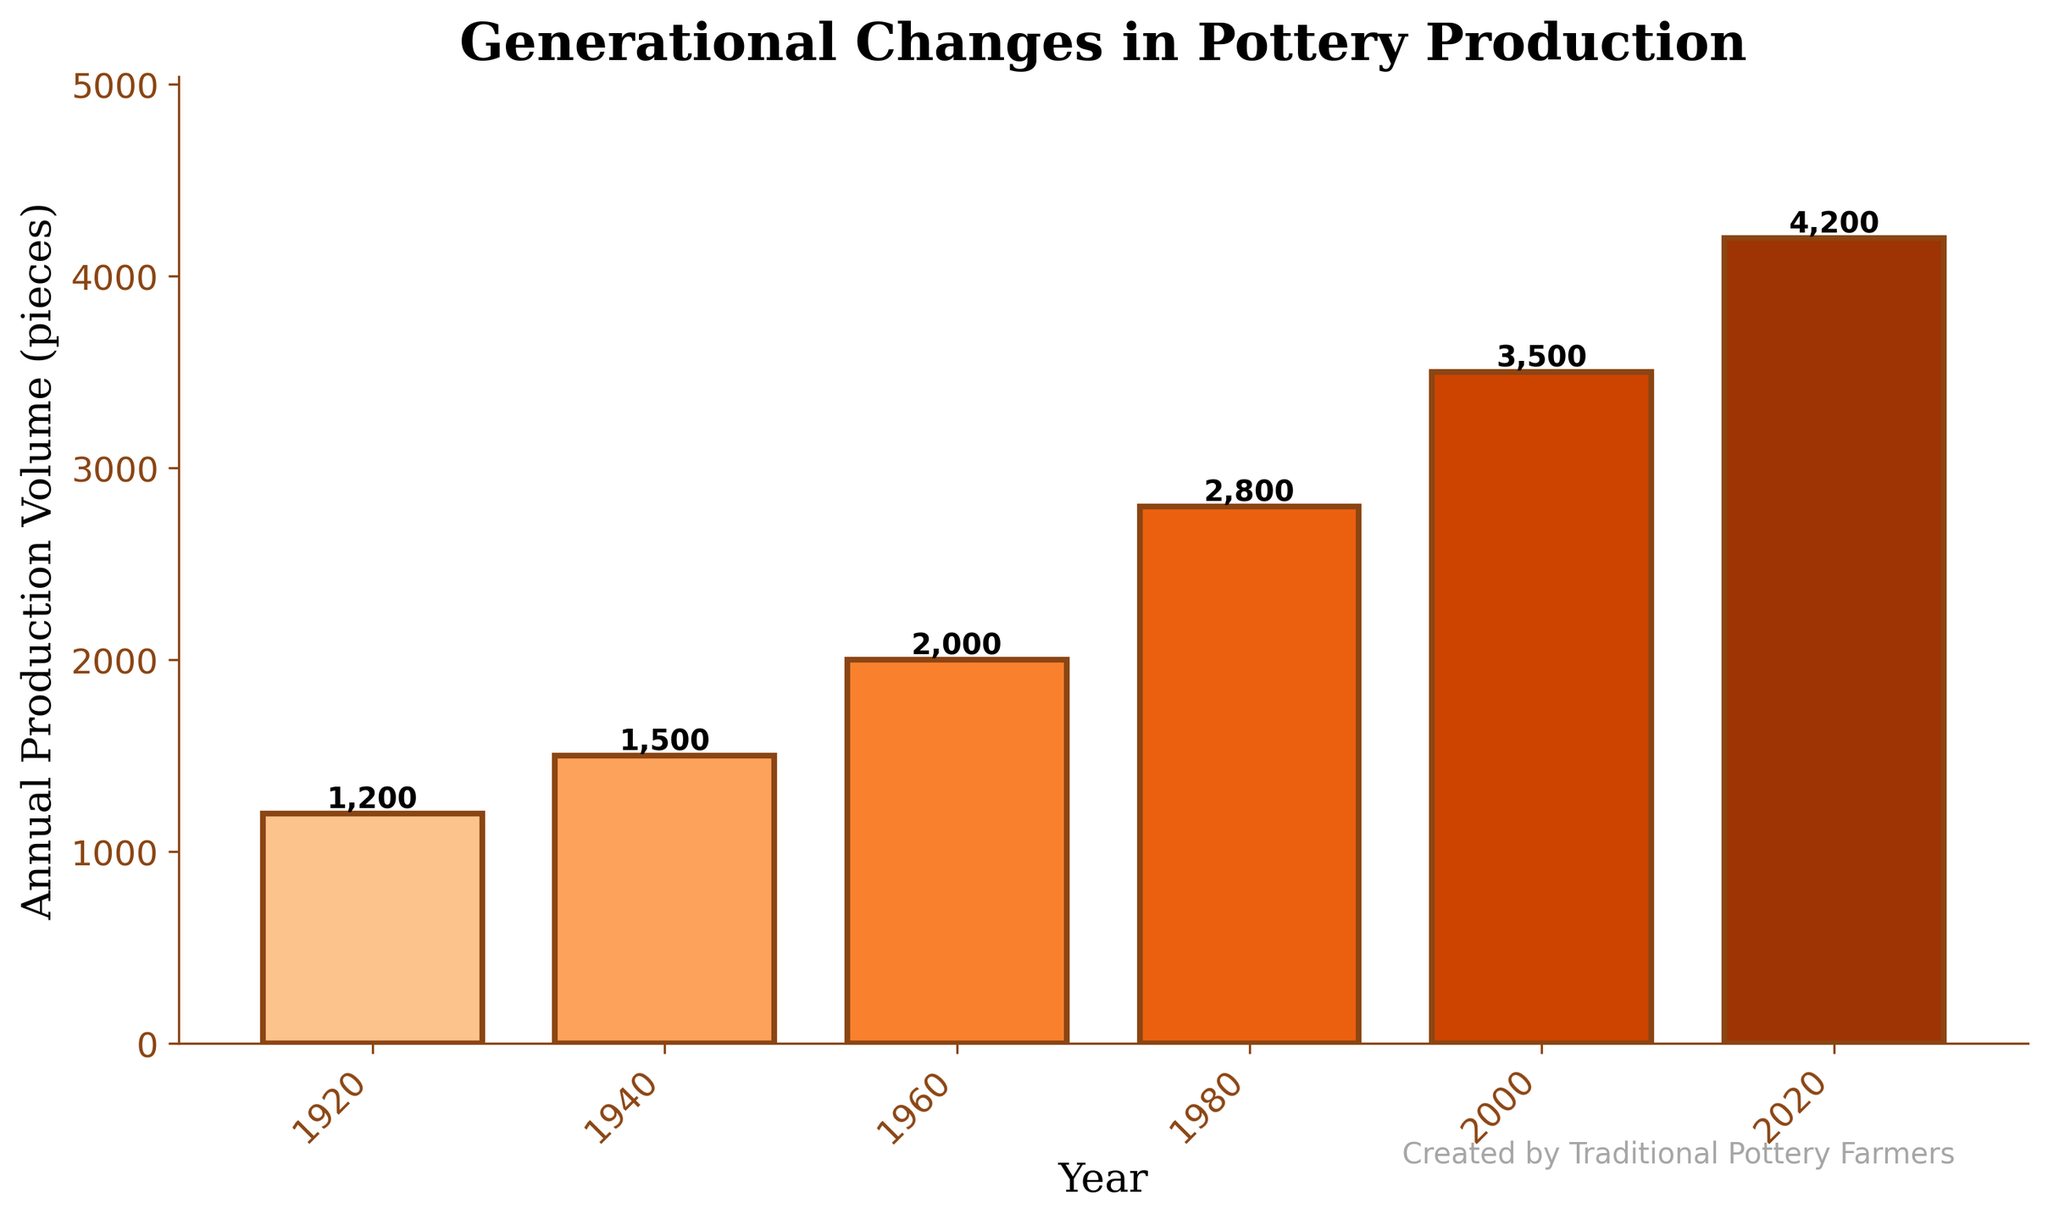What is the overall trend in pottery production volume over the years? The trend can be observed by looking at the height of the bars. The tallest bar is for the most recent year (2020) and the shortest is for the earliest year (1920). Each subsequent bar gets progressively taller, indicating an overall increasing trend.
Answer: Increasing What was the production volume in 1980? The height of the bar corresponding to 1980 and the text above the bar indicate the production volume.
Answer: 2800 pieces Which year saw the highest pottery production volume? The tallest bar represents the highest production volume, which corresponds to the year 2020.
Answer: 2020 How much did pottery production increase from 1940 to 1960? Subtract the production volume of 1940 from that of 1960: 2000 - 1500 = 500.
Answer: 500 pieces What is the difference in production volume between the earliest year and the most recent year? Subtract the 1920 production volume from the 2020 production volume: 4200 - 1200 = 3000.
Answer: 3000 pieces Which two consecutive decades had the most significant increase in production volume? Compare the differences between each consecutive pair of years: 1940-1920 = 300, 1960-1940 = 500, 1980-1960 = 800, 2000-1980 = 700, 2020-2000 = 700. The greatest increase occurs between 1960 and 1980.
Answer: 1960 and 1980 What is the average production volume over the entire century? Add up all the production volumes: 1200 + 1500 + 2000 + 2800 + 3500 + 4200 = 15200. Divide by the number of years: 15200 / 6 = 2533.33.
Answer: 2533.33 pieces Between which years did the pottery production double for the first time? Identify the first pair of years where the later year's production is at least twice the earlier year's. Comparisons: 1940 vs. 1920 (1500 > 1200*2) is false, 1960 vs. 1940 (2000 > 1500*2) is false, 1980 vs. 1960 (2800 > 2000*2) is false, 2000 vs. 1980 (3500 >= 2800*2.4 is true).
Answer: 1980 and 2000 What does the color of the bars indicate? The bars are shaded with different hues of orange, with lighter shades for earlier years and darker shades for more recent years, which visually reinforces the chronological order.
Answer: Different years What visual attribute indicates the production volume for each year? The height of the bars indicates the production volume, with taller bars representing higher volumes.
Answer: Height of the bars 